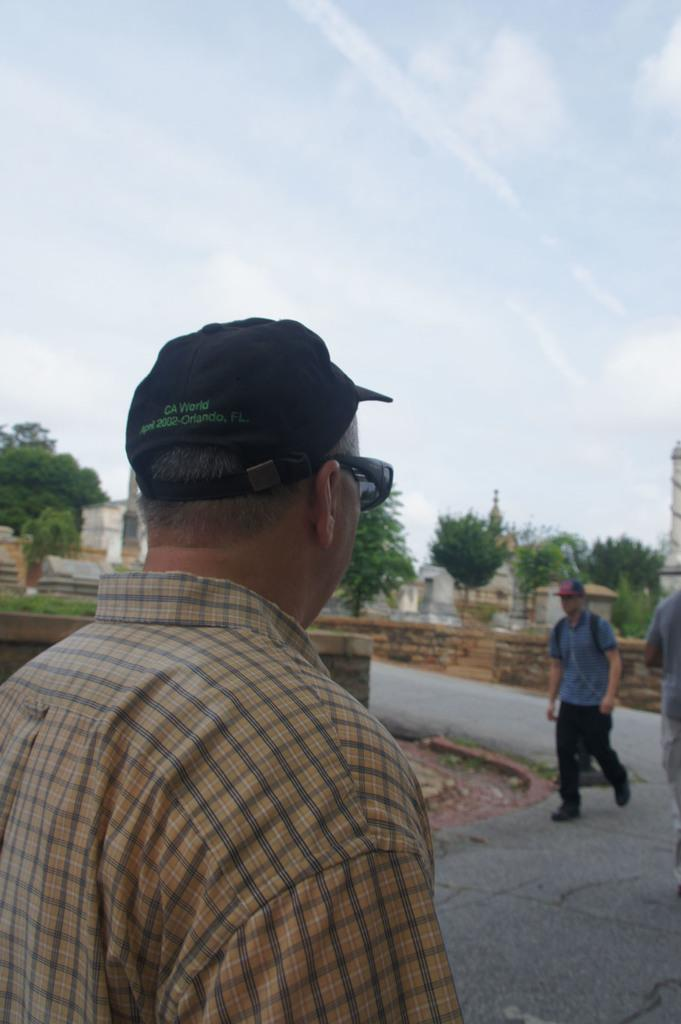Who is the main subject in the foreground of the image? There is a man in the foreground of the image. How many people are on the right side of the image? There are two people on the right side of the image. Where are the people located in the image? They are on the road. What can be seen in the background of the image? There are trees, buildings, and the sky visible in the background of the image. How much money is being exchanged between the people in the image? There is no indication of any money exchange in the image. What type of body of water can be seen in the image? There is no body of water present in the image. 